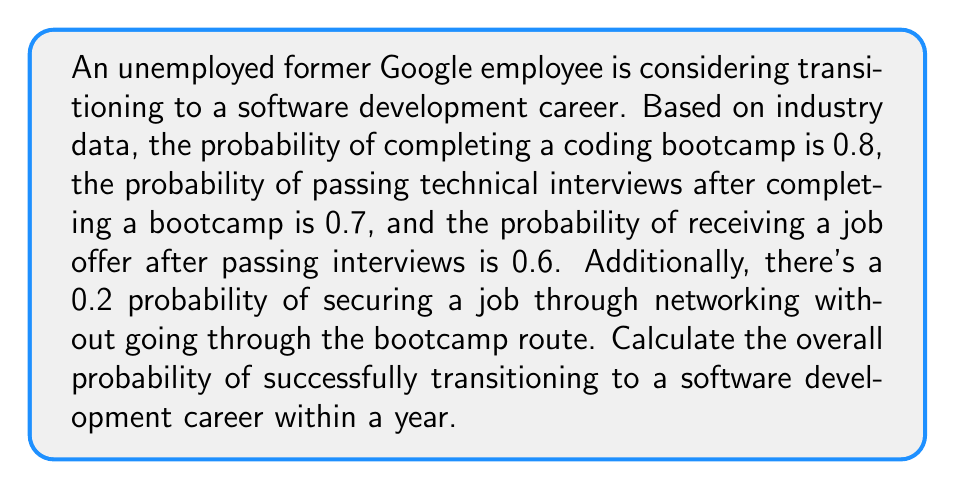Can you answer this question? Let's approach this step-by-step using the principles of probability theory:

1) First, let's consider the bootcamp route:
   - Probability of completing bootcamp: $P(B) = 0.8$
   - Probability of passing interviews given bootcamp completion: $P(I|B) = 0.7$
   - Probability of job offer given passing interviews: $P(J|I) = 0.6$

2) The probability of success through the bootcamp route is the product of these probabilities:

   $P(\text{bootcamp success}) = P(B) \times P(I|B) \times P(J|I)$
   $= 0.8 \times 0.7 \times 0.6 = 0.336$

3) Now, let's consider the networking route:
   - Probability of success through networking: $P(N) = 0.2$

4) The total probability of success is the sum of the probabilities of success through each mutually exclusive route:

   $P(\text{total success}) = P(\text{bootcamp success}) + P(\text{networking success})$
   $= 0.336 + 0.2 = 0.536$

Therefore, the overall probability of successfully transitioning to a software development career within a year is 0.536 or 53.6%.
Answer: The overall probability of successfully transitioning to a software development career within a year is 0.536 or 53.6%. 